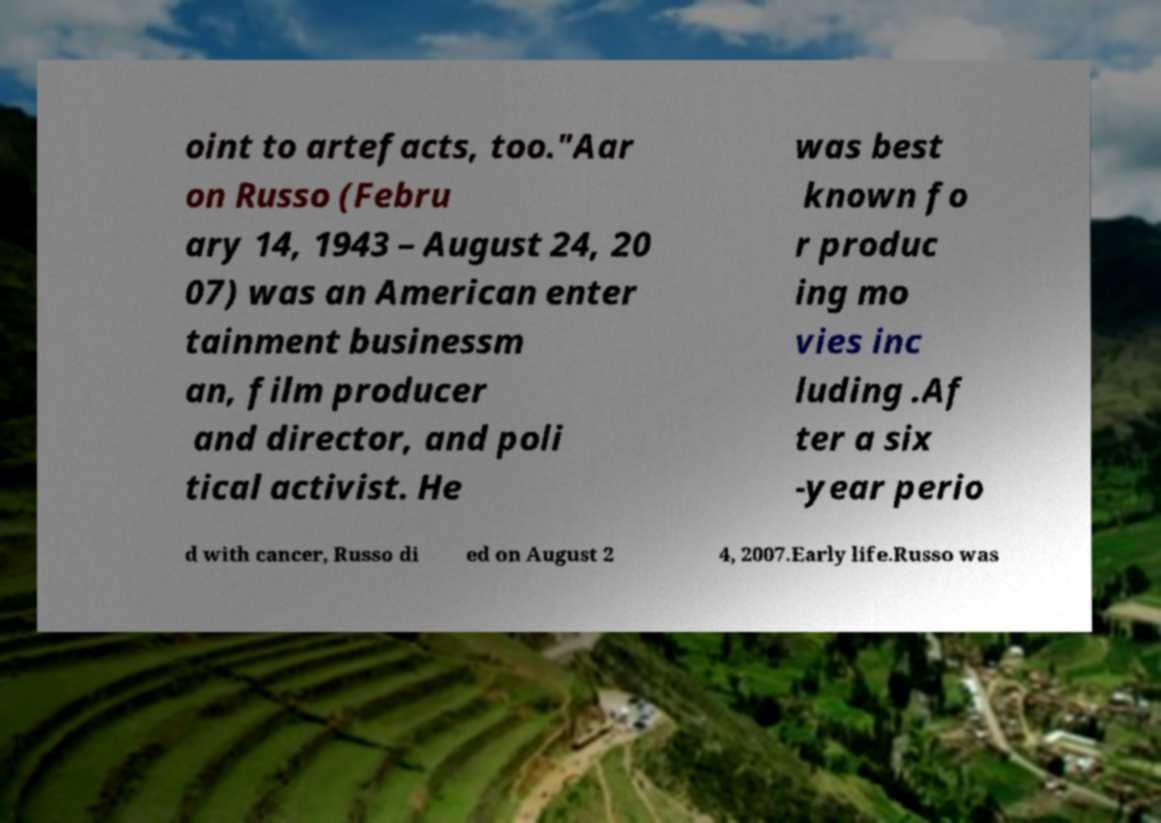Can you read and provide the text displayed in the image?This photo seems to have some interesting text. Can you extract and type it out for me? oint to artefacts, too."Aar on Russo (Febru ary 14, 1943 – August 24, 20 07) was an American enter tainment businessm an, film producer and director, and poli tical activist. He was best known fo r produc ing mo vies inc luding .Af ter a six -year perio d with cancer, Russo di ed on August 2 4, 2007.Early life.Russo was 